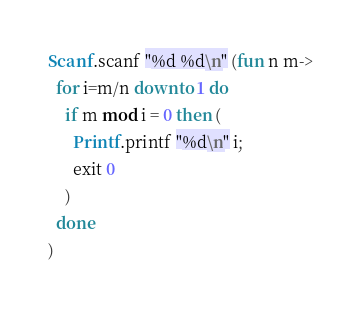<code> <loc_0><loc_0><loc_500><loc_500><_OCaml_>Scanf.scanf "%d %d\n" (fun n m->
  for i=m/n downto 1 do
    if m mod i = 0 then (
      Printf.printf "%d\n" i;
      exit 0
    )
  done
)
</code> 